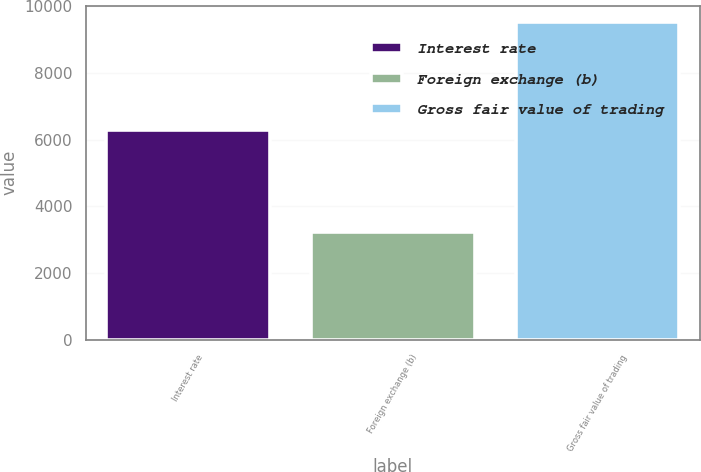<chart> <loc_0><loc_0><loc_500><loc_500><bar_chart><fcel>Interest rate<fcel>Foreign exchange (b)<fcel>Gross fair value of trading<nl><fcel>6279<fcel>3231<fcel>9534<nl></chart> 